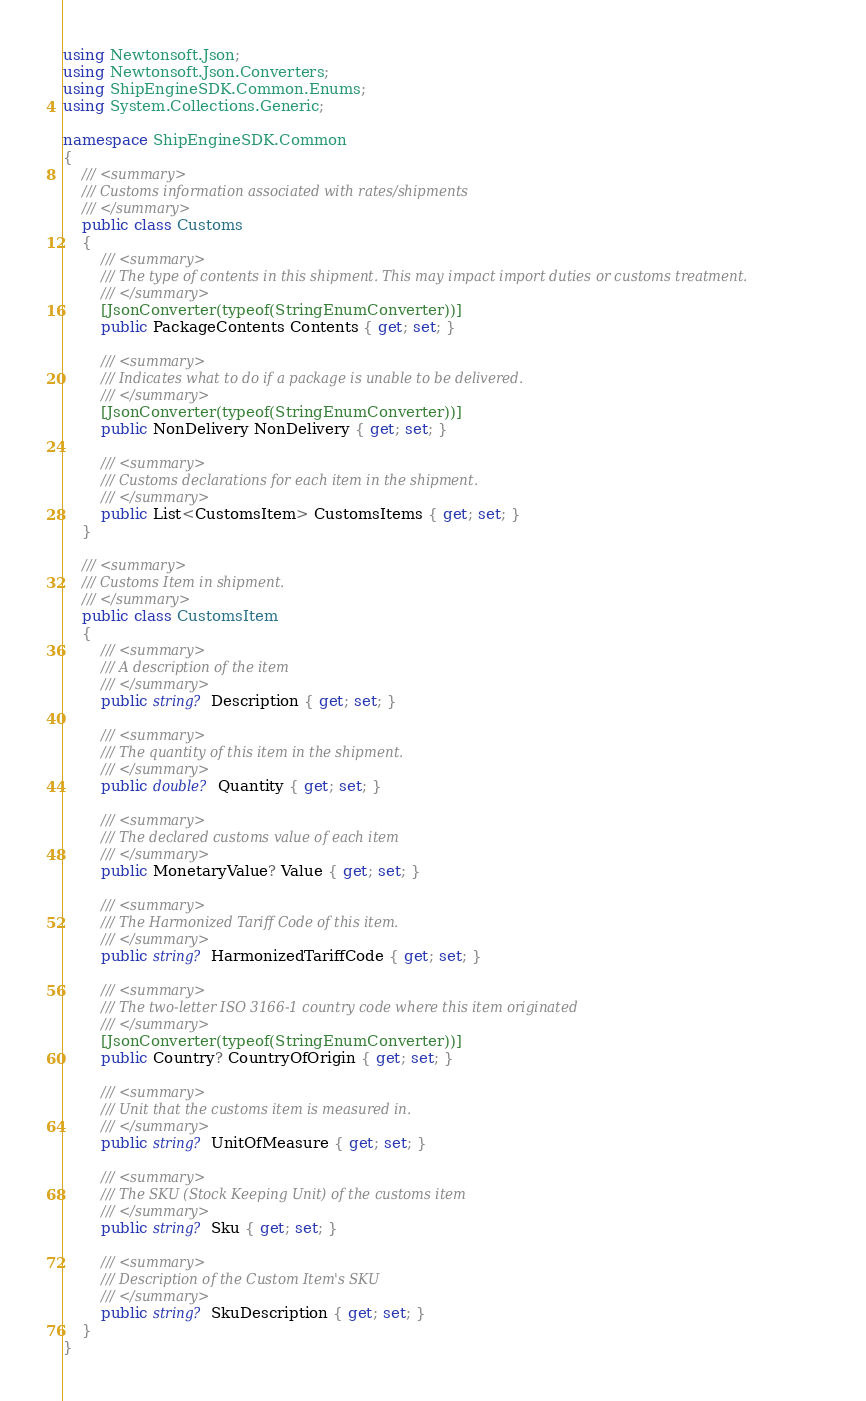<code> <loc_0><loc_0><loc_500><loc_500><_C#_>using Newtonsoft.Json;
using Newtonsoft.Json.Converters;
using ShipEngineSDK.Common.Enums;
using System.Collections.Generic;

namespace ShipEngineSDK.Common
{
    /// <summary>
    /// Customs information associated with rates/shipments
    /// </summary>
    public class Customs
    {
        /// <summary>
        /// The type of contents in this shipment. This may impact import duties or customs treatment.
        /// </summary>
        [JsonConverter(typeof(StringEnumConverter))]
        public PackageContents Contents { get; set; }

        /// <summary>
        /// Indicates what to do if a package is unable to be delivered.
        /// </summary>
        [JsonConverter(typeof(StringEnumConverter))]
        public NonDelivery NonDelivery { get; set; }

        /// <summary>
        /// Customs declarations for each item in the shipment.
        /// </summary>
        public List<CustomsItem> CustomsItems { get; set; }
    }

    /// <summary>
    /// Customs Item in shipment.
    /// </summary>
    public class CustomsItem
    {
        /// <summary>
        /// A description of the item
        /// </summary>
        public string? Description { get; set; }

        /// <summary>
        /// The quantity of this item in the shipment.
        /// </summary>
        public double? Quantity { get; set; }

        /// <summary>
        /// The declared customs value of each item
        /// </summary>
        public MonetaryValue? Value { get; set; }

        /// <summary>
        /// The Harmonized Tariff Code of this item.
        /// </summary>
        public string? HarmonizedTariffCode { get; set; }

        /// <summary>
        /// The two-letter ISO 3166-1 country code where this item originated
        /// </summary>
        [JsonConverter(typeof(StringEnumConverter))]
        public Country? CountryOfOrigin { get; set; }

        /// <summary>
        /// Unit that the customs item is measured in.
        /// </summary>
        public string? UnitOfMeasure { get; set; }

        /// <summary>
        /// The SKU (Stock Keeping Unit) of the customs item
        /// </summary>
        public string? Sku { get; set; }

        /// <summary>
        /// Description of the Custom Item's SKU
        /// </summary>
        public string? SkuDescription { get; set; }
    }
}</code> 